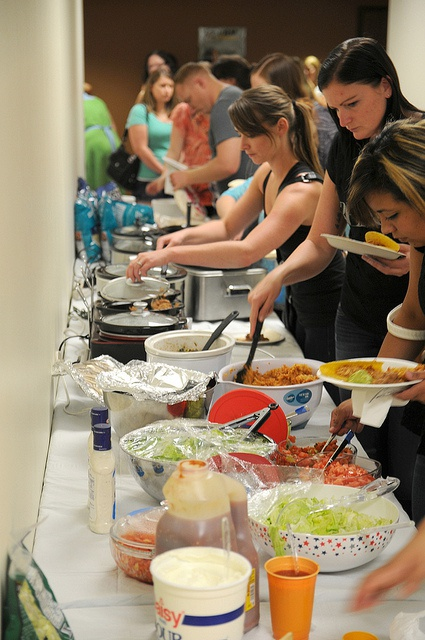Describe the objects in this image and their specific colors. I can see dining table in tan, darkgray, and beige tones, people in tan, black, brown, and maroon tones, people in tan, black, and salmon tones, people in tan, black, maroon, and brown tones, and bowl in tan, beige, and darkgray tones in this image. 